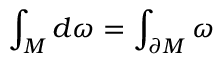Convert formula to latex. <formula><loc_0><loc_0><loc_500><loc_500>\int _ { M } d \omega = \int _ { \partial { M } } \omega</formula> 